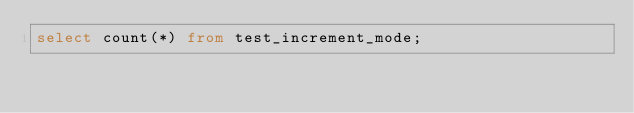<code> <loc_0><loc_0><loc_500><loc_500><_SQL_>select count(*) from test_increment_mode;
</code> 